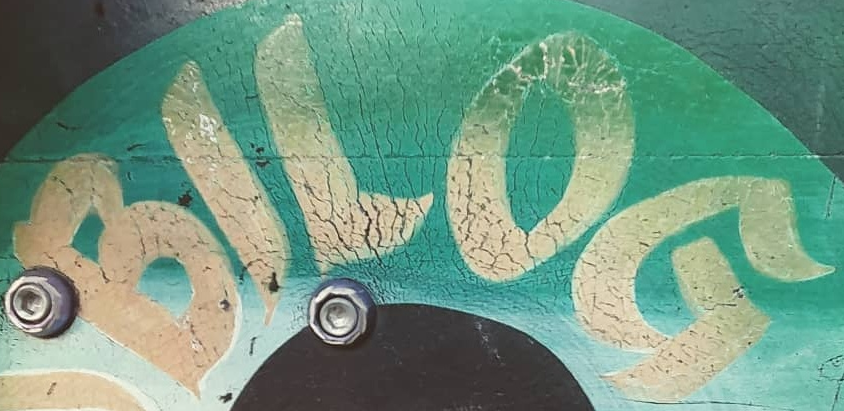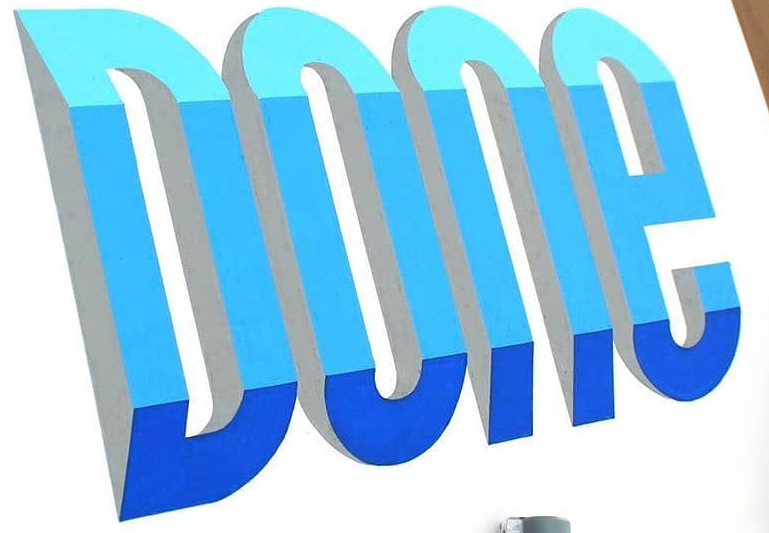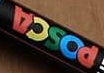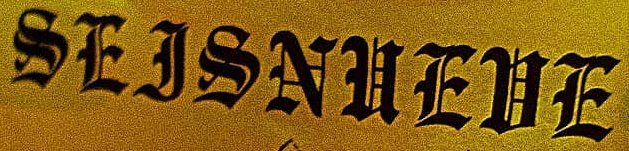Read the text from these images in sequence, separated by a semicolon. BILOG; DOne; POSCA; SEJSNUEUE 